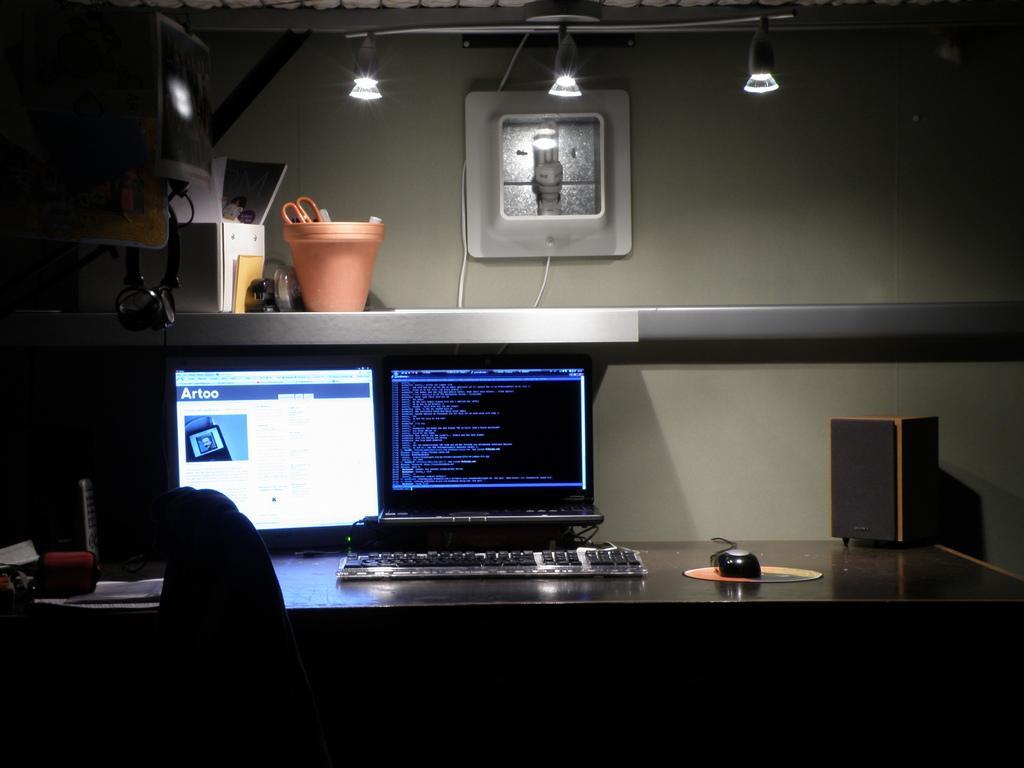Could you give a brief overview of what you see in this image? An indoor picture. On this table there is a monitor, keyboard, screen, sound-box, phone and mouse. On top there are lights. Above the table there is a container, scissors and things. This are headset. 